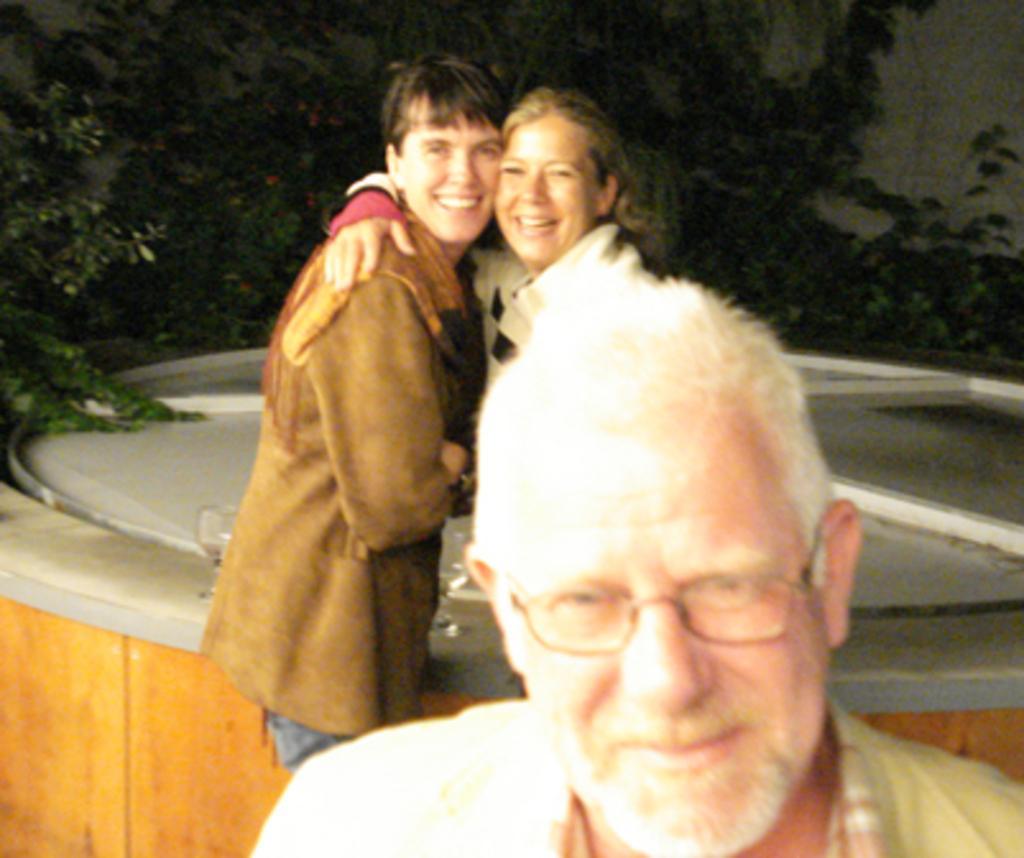Please provide a concise description of this image. At the bottom we can see a man. In the background we can see a man and a woman are standing at an object and smiling and we can see plants and wall. 